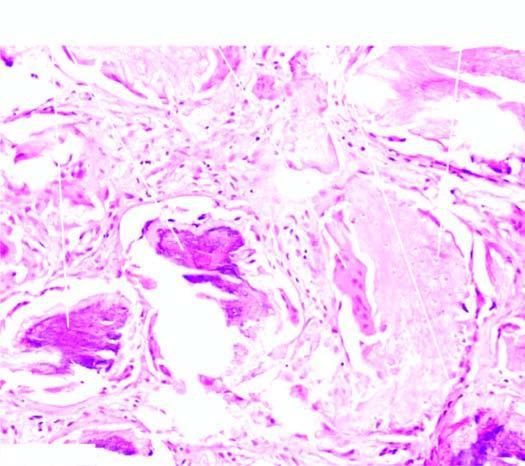what does the tumour show?
Answer the question using a single word or phrase. Islands and lobules within the dermis 